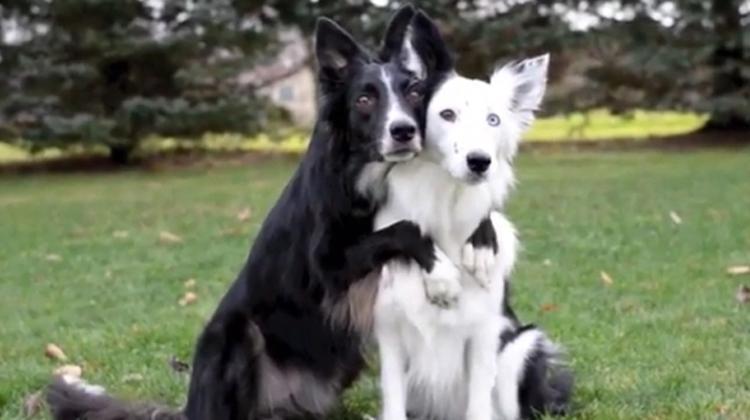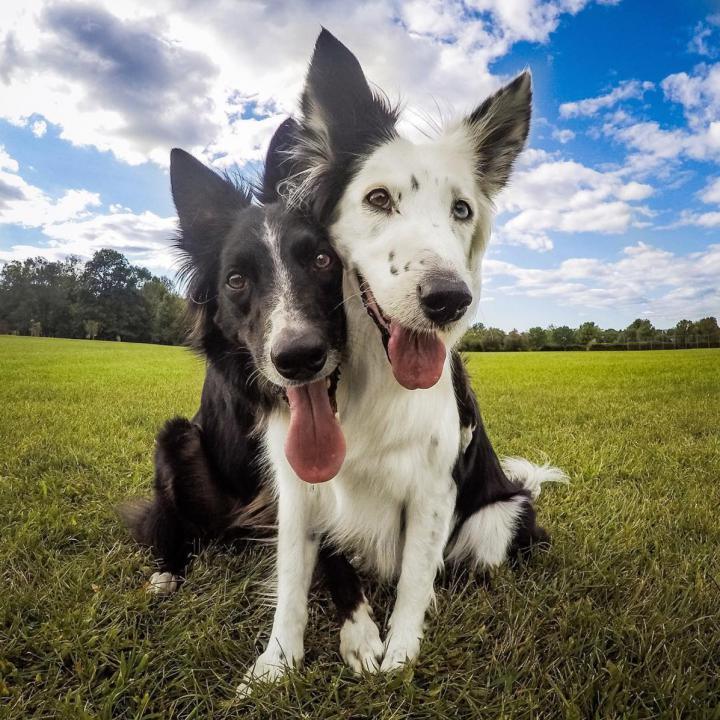The first image is the image on the left, the second image is the image on the right. Assess this claim about the two images: "Both images show two dogs outside.". Correct or not? Answer yes or no. Yes. 